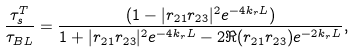<formula> <loc_0><loc_0><loc_500><loc_500>\frac { \tau _ { s } ^ { T } } { \tau _ { B L } } = \frac { ( 1 - | r _ { 2 1 } r _ { 2 3 } | ^ { 2 } e ^ { - 4 k _ { r } L } ) } { 1 + | r _ { 2 1 } r _ { 2 3 } | ^ { 2 } e ^ { - 4 k _ { r } L } - 2 \Re ( r _ { 2 1 } r _ { 2 3 } ) e ^ { - 2 k _ { r } L } } ,</formula> 